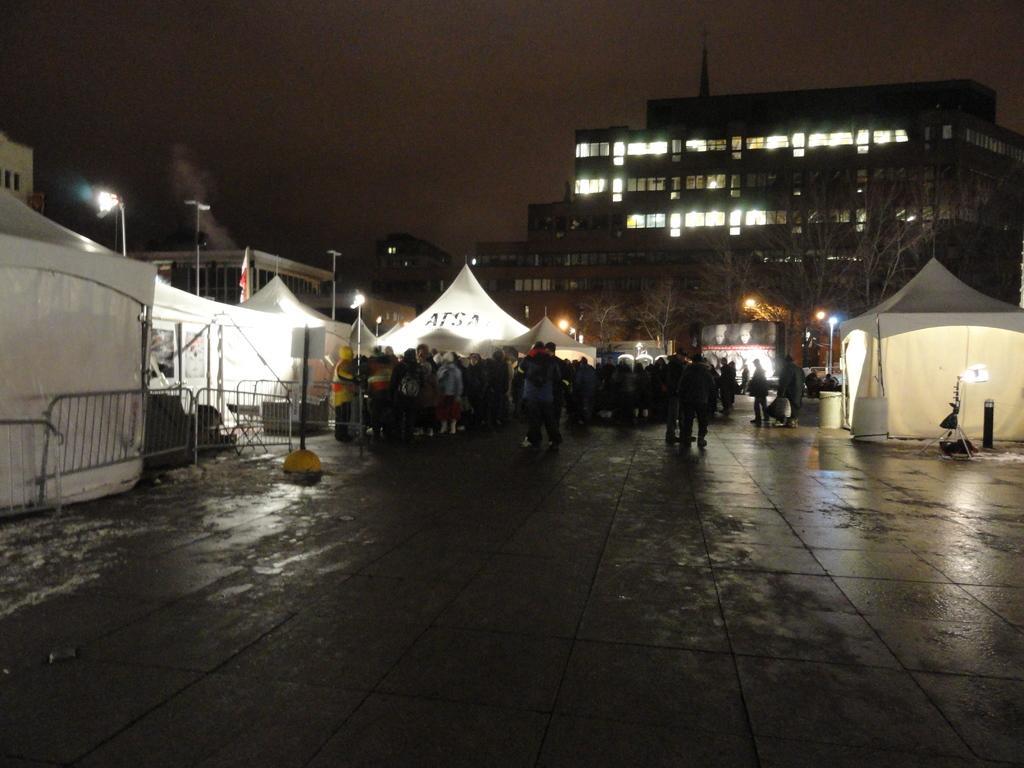Describe this image in one or two sentences. In this picture I can see there are a group of people standing here and they are few tents, buildings and the sky is dark. 